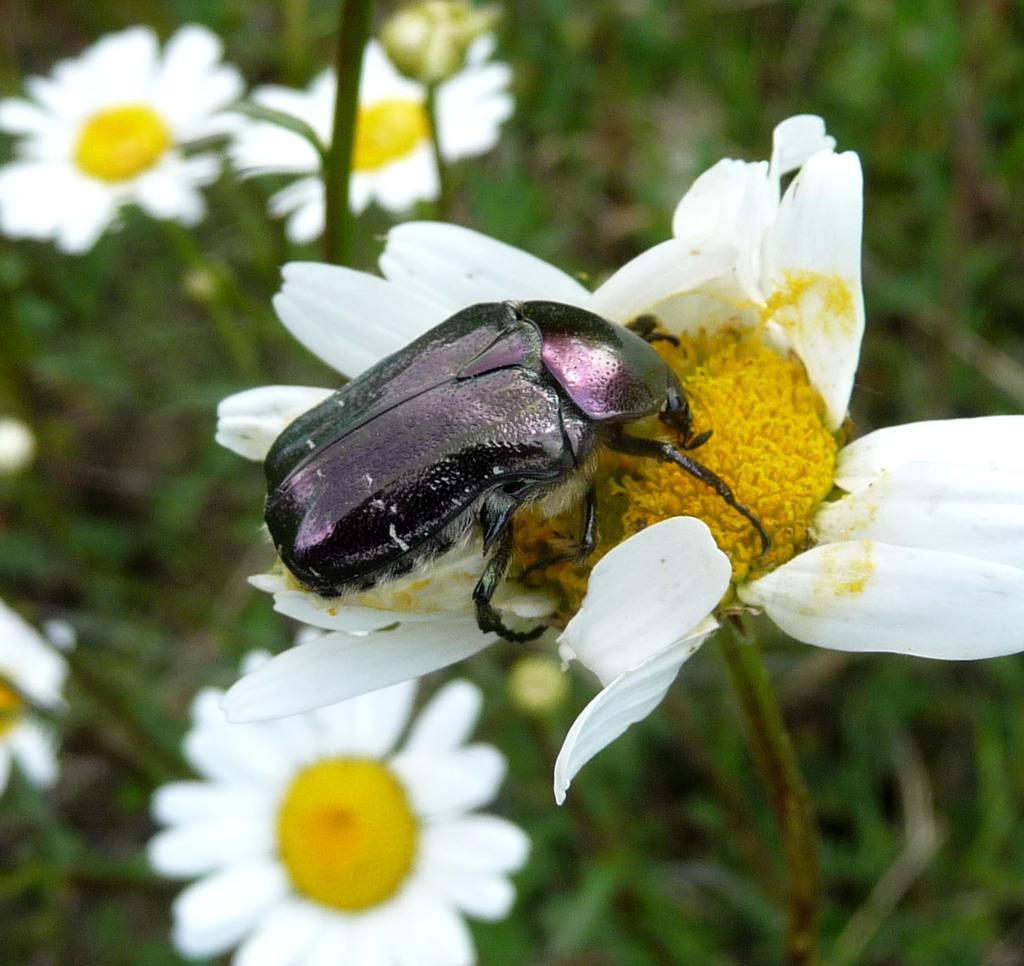Describe this image in one or two sentences. In this image there is a small bee which is eating the pollen grains. In the background there are white flowers to the plant. 